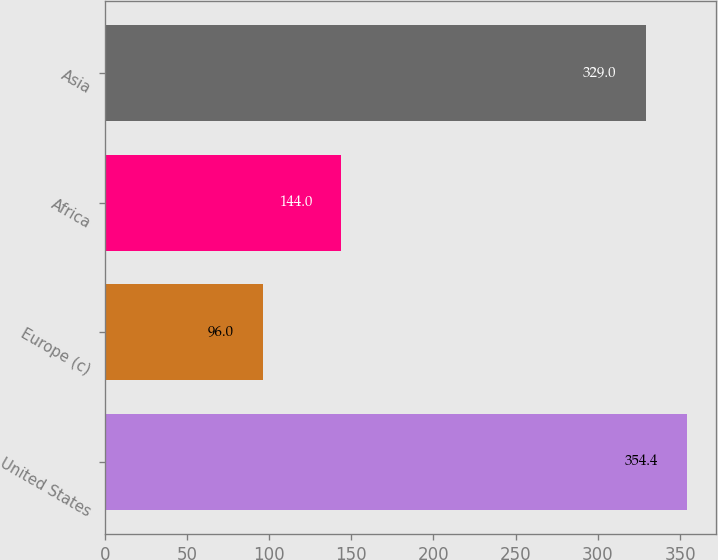Convert chart to OTSL. <chart><loc_0><loc_0><loc_500><loc_500><bar_chart><fcel>United States<fcel>Europe (c)<fcel>Africa<fcel>Asia<nl><fcel>354.4<fcel>96<fcel>144<fcel>329<nl></chart> 